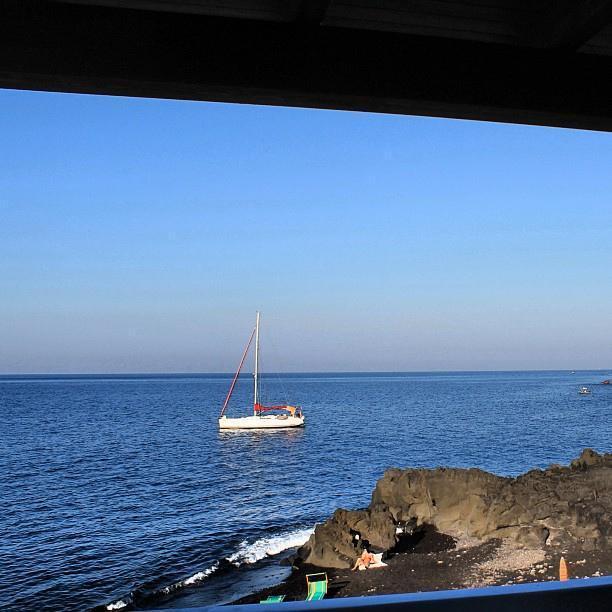How many boats can be seen?
Give a very brief answer. 1. How many bike shadows are there?
Give a very brief answer. 0. 